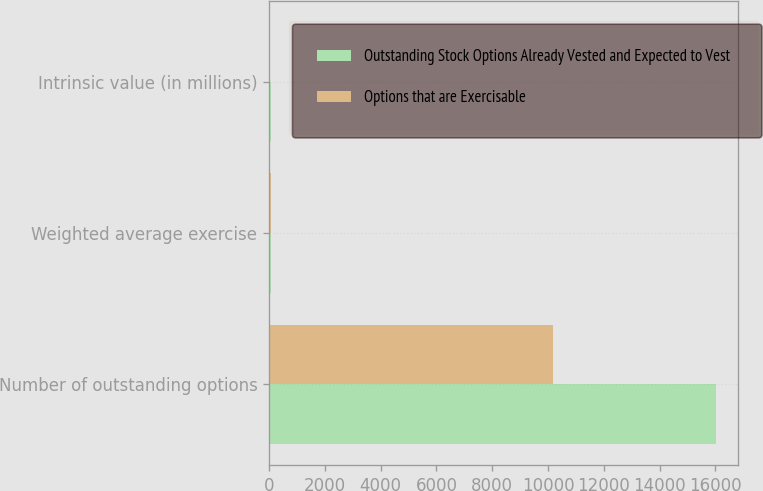<chart> <loc_0><loc_0><loc_500><loc_500><stacked_bar_chart><ecel><fcel>Number of outstanding options<fcel>Weighted average exercise<fcel>Intrinsic value (in millions)<nl><fcel>Outstanding Stock Options Already Vested and Expected to Vest<fcel>16008<fcel>67.37<fcel>75.3<nl><fcel>Options that are Exercisable<fcel>10181<fcel>68.85<fcel>38.6<nl></chart> 